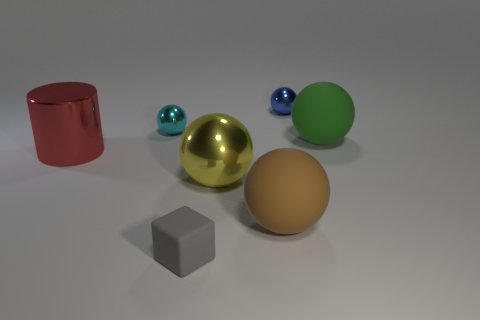How many other objects are the same size as the blue object?
Make the answer very short. 2. What number of objects are tiny objects behind the gray object or spheres that are right of the tiny gray thing?
Provide a succinct answer. 5. Is the material of the blue ball the same as the thing that is in front of the brown thing?
Ensure brevity in your answer.  No. How many other objects are there of the same shape as the small cyan object?
Offer a very short reply. 4. What is the big sphere behind the shiny sphere in front of the tiny sphere that is on the left side of the small blue sphere made of?
Ensure brevity in your answer.  Rubber. Is the number of big brown objects that are on the left side of the gray object the same as the number of large yellow shiny objects?
Give a very brief answer. No. Is the material of the tiny ball that is right of the tiny cyan shiny thing the same as the small thing left of the matte block?
Give a very brief answer. Yes. Are there any other things that are made of the same material as the large red object?
Your answer should be very brief. Yes. Do the matte object behind the big metal cylinder and the big rubber object in front of the red metal object have the same shape?
Give a very brief answer. Yes. Is the number of large yellow metallic things that are in front of the big brown ball less than the number of big balls?
Make the answer very short. Yes. 